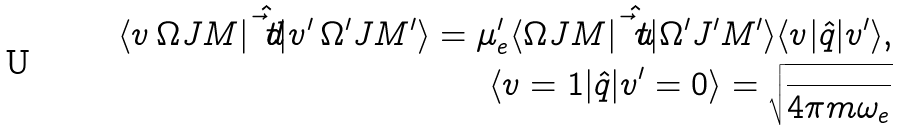<formula> <loc_0><loc_0><loc_500><loc_500>\langle v \, \Omega J M | \hat { \vec { t } { d } } | v ^ { \prime } \, \Omega ^ { \prime } J M ^ { \prime } \rangle = \mu _ { e } ^ { \prime } \langle \Omega J M | \hat { \vec { t } { u } } | \Omega ^ { \prime } J ^ { \prime } M ^ { \prime } \rangle \langle v | \hat { q } | v ^ { \prime } \rangle , \\ \langle v = 1 | \hat { q } | v ^ { \prime } = 0 \rangle = \sqrt { \frac { } { 4 \pi m \omega _ { e } } }</formula> 